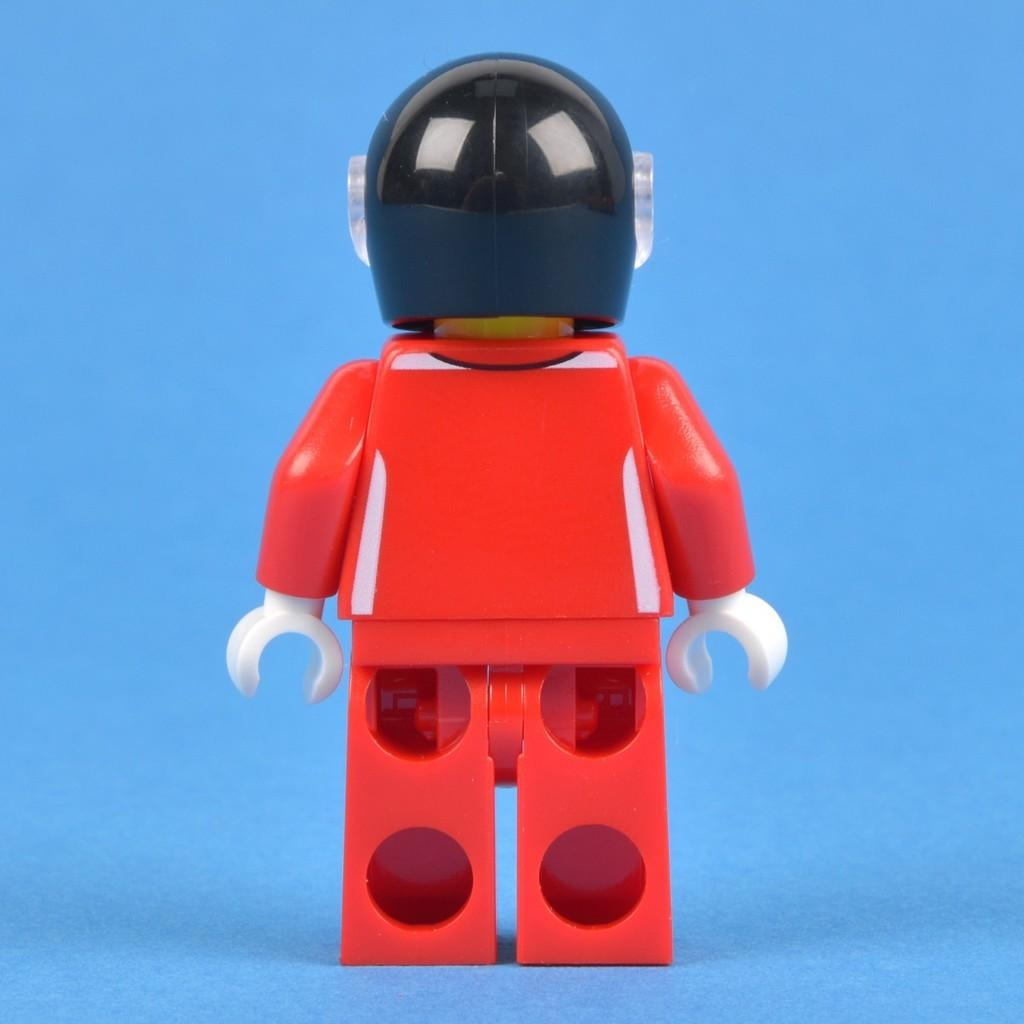What is the main subject in the center of the image? There is a toy in the center of the image. What color is the background of the image? The background of the image is blue. What type of alarm can be heard going off in the image? There is no alarm present in the image, and therefore no sound can be heard. 